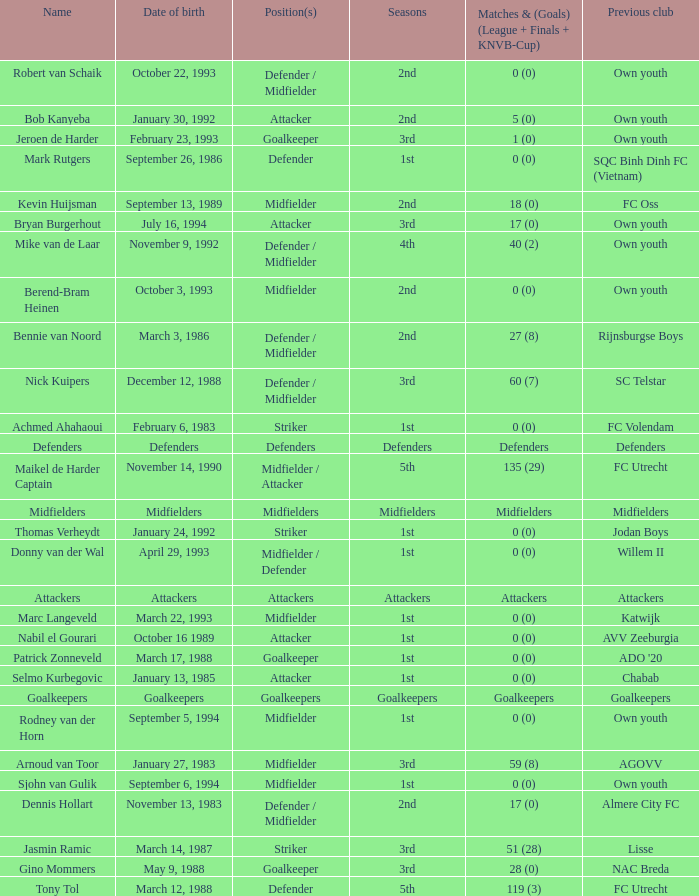What is the date of birth of the goalkeeper from the 1st season? March 17, 1988. 